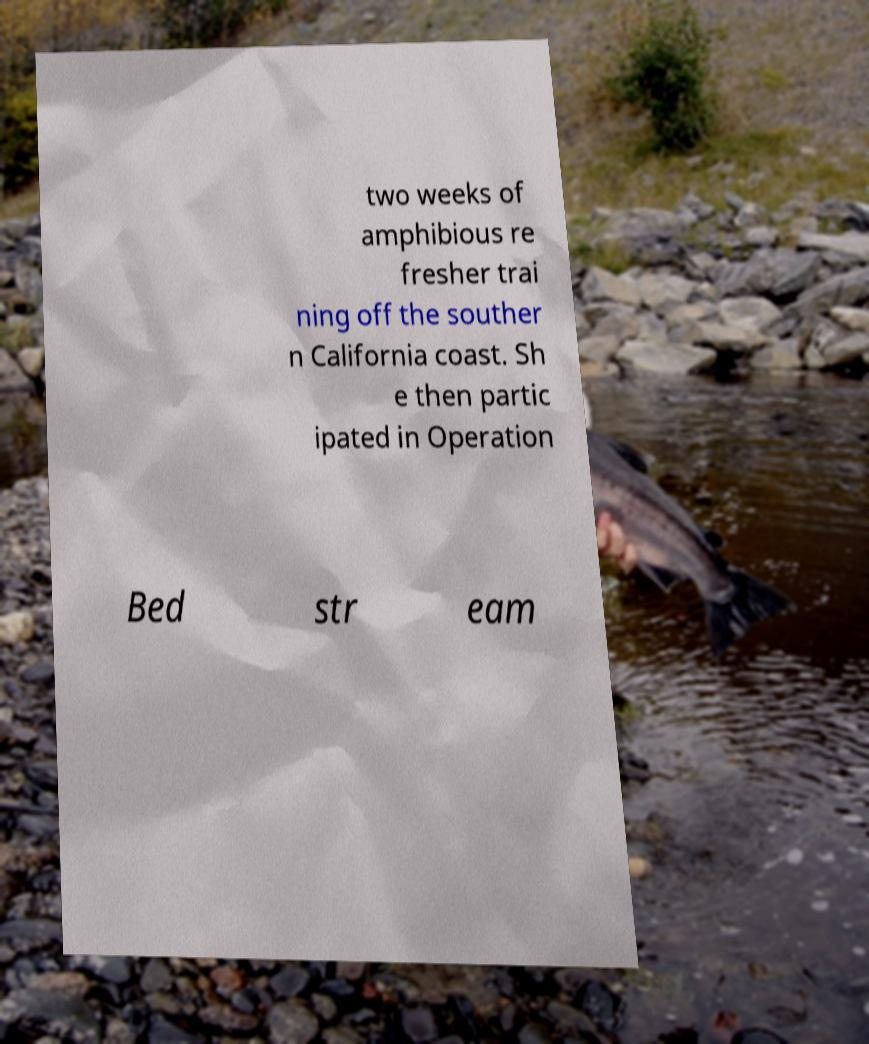I need the written content from this picture converted into text. Can you do that? two weeks of amphibious re fresher trai ning off the souther n California coast. Sh e then partic ipated in Operation Bed str eam 